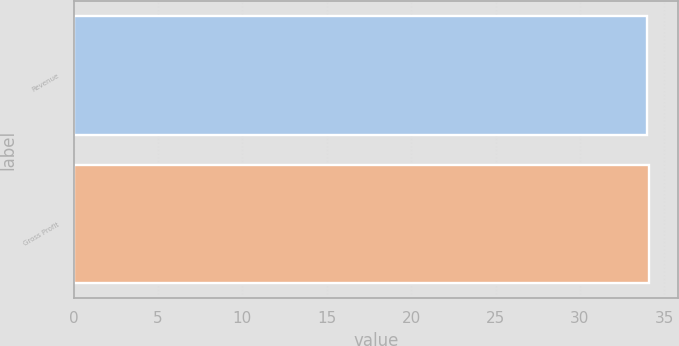<chart> <loc_0><loc_0><loc_500><loc_500><bar_chart><fcel>Revenue<fcel>Gross Profit<nl><fcel>34<fcel>34.1<nl></chart> 